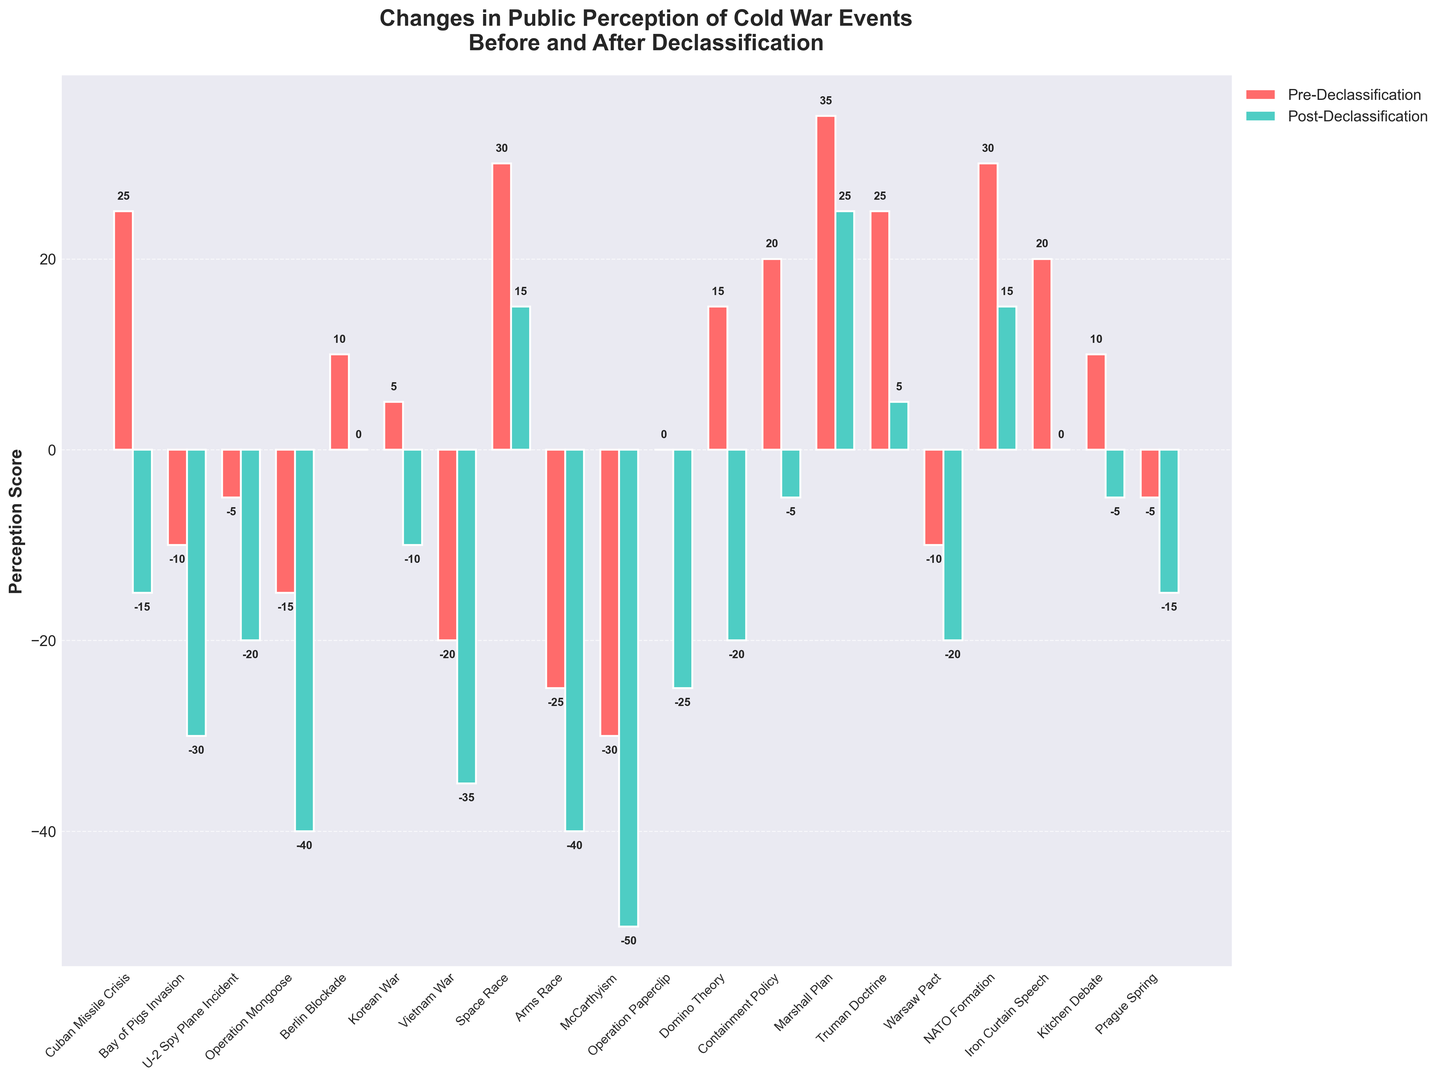What event showed the greatest decline in public perception after the declassification? Compare the pre-declassification and post-declassification values for each event. The event with the largest negative change is the one with the greatest decline. The McCarthyism event shows the largest drop from -30 to -50, a decline of 20 points.
Answer: McCarthyism Which two events improved in public perception after the declassification? Examine each event's pre-declassification and post-declassification values. The ones with positive changes (improvement) are the Space Race (30 to 15, decline but positive change) and NATO Formation (30 to 15, decline but still positive). No events showed an actual increase in values.
Answer: Space Race, NATO Formation What is the combined perception score of the Marshall Plan before and after the declassification? Add the pre-declassification value to the post-declassification value for the Marshall Plan. Its pre-declassification score is 35 and post-declassification is 25. Summing these gives 35 + 25 = 60.
Answer: 60 Which event had a consistently neutral to negative perception across the declassification? Look for events with non-positive (zero or negative) values in both pre-declassification and post-declassification columns. Operation Paperclip has a pre-declassification score of 0 and a post-declassification score of -25, meeting this criterion.
Answer: Operation Paperclip How many events had a negative perception both before and after the declassification? Count the events with negative values in both columns. These events are Bay of Pigs Invasion, U-2 Spy Plane Incident, Operation Mongoose, Vietnam War, Arms Race, McCarthyism, Warsaw Pact, and Prague Spring, totaling 8 events.
Answer: 8 Was public perception of the Berlin Blockade more negative or positive after the declassification? Compare the Berlin Blockade's pre-declassification (10) and post-declassification (0) values to determine the overall change. The perception dropped to zero, which is neutral but more negative compared to the initial positive score.
Answer: More negative Which event had the most significant change in perception score after declassification among the positive pre-declassification values? Focus on events with positive pre-declassification values and find the one with the largest absolute difference when subtracting the post-declassification value. The Truman Doctrine had a change from 25 to 5, a 20-point drop, the largest among positive pre-values.
Answer: Truman Doctrine What is the average perception score after declassification for all the events? Sum all post-declassification perception values and divide by the number of events (20). Sum (-15 - 30 - 20 - 40 + 0 - 10 - 35 + 15 - 40 - 50 - 25 - 20 - 5 + 25 + 5 - 20 + 15 + 0 - 5 - 15) = -275. Divide by 20: -275 / 20 = -13.75.
Answer: -13.75 